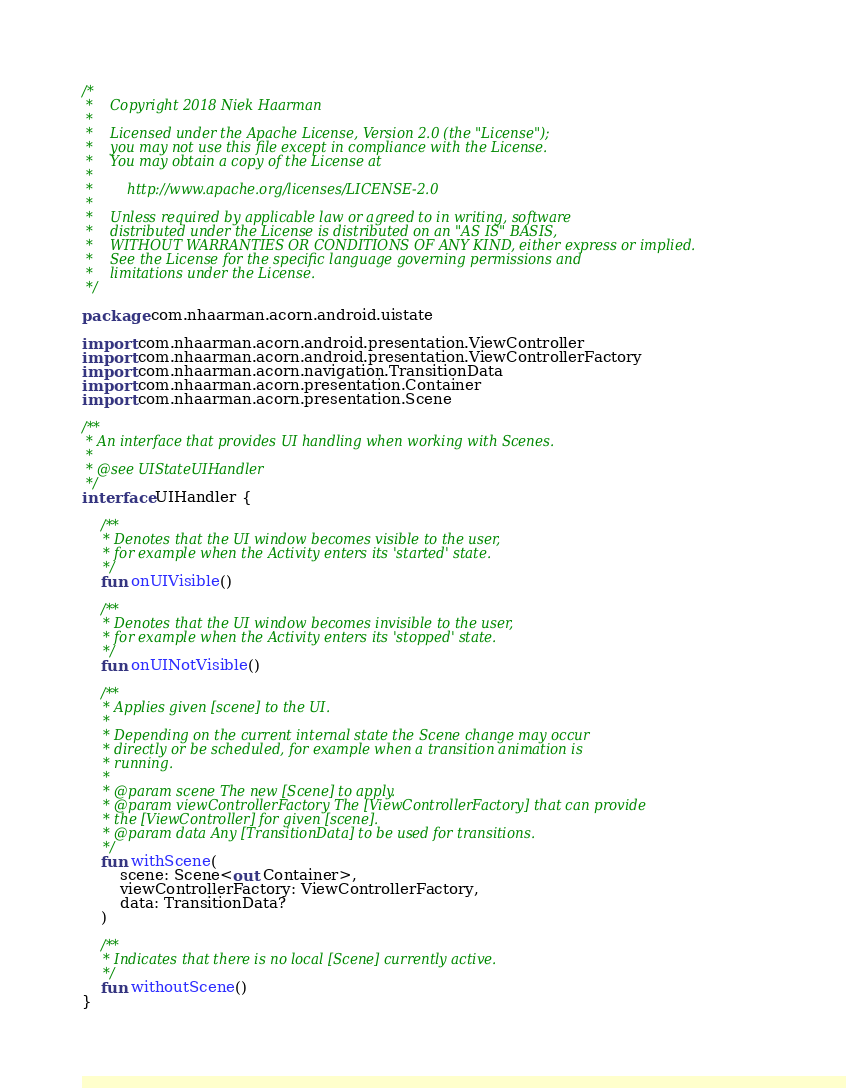<code> <loc_0><loc_0><loc_500><loc_500><_Kotlin_>/*
 *    Copyright 2018 Niek Haarman
 *
 *    Licensed under the Apache License, Version 2.0 (the "License");
 *    you may not use this file except in compliance with the License.
 *    You may obtain a copy of the License at
 *
 *        http://www.apache.org/licenses/LICENSE-2.0
 *
 *    Unless required by applicable law or agreed to in writing, software
 *    distributed under the License is distributed on an "AS IS" BASIS,
 *    WITHOUT WARRANTIES OR CONDITIONS OF ANY KIND, either express or implied.
 *    See the License for the specific language governing permissions and
 *    limitations under the License.
 */

package com.nhaarman.acorn.android.uistate

import com.nhaarman.acorn.android.presentation.ViewController
import com.nhaarman.acorn.android.presentation.ViewControllerFactory
import com.nhaarman.acorn.navigation.TransitionData
import com.nhaarman.acorn.presentation.Container
import com.nhaarman.acorn.presentation.Scene

/**
 * An interface that provides UI handling when working with Scenes.
 *
 * @see UIStateUIHandler
 */
interface UIHandler {

    /**
     * Denotes that the UI window becomes visible to the user,
     * for example when the Activity enters its 'started' state.
     */
    fun onUIVisible()

    /**
     * Denotes that the UI window becomes invisible to the user,
     * for example when the Activity enters its 'stopped' state.
     */
    fun onUINotVisible()

    /**
     * Applies given [scene] to the UI.
     *
     * Depending on the current internal state the Scene change may occur
     * directly or be scheduled, for example when a transition animation is
     * running.
     *
     * @param scene The new [Scene] to apply.
     * @param viewControllerFactory The [ViewControllerFactory] that can provide
     * the [ViewController] for given [scene].
     * @param data Any [TransitionData] to be used for transitions.
     */
    fun withScene(
        scene: Scene<out Container>,
        viewControllerFactory: ViewControllerFactory,
        data: TransitionData?
    )

    /**
     * Indicates that there is no local [Scene] currently active.
     */
    fun withoutScene()
}
</code> 